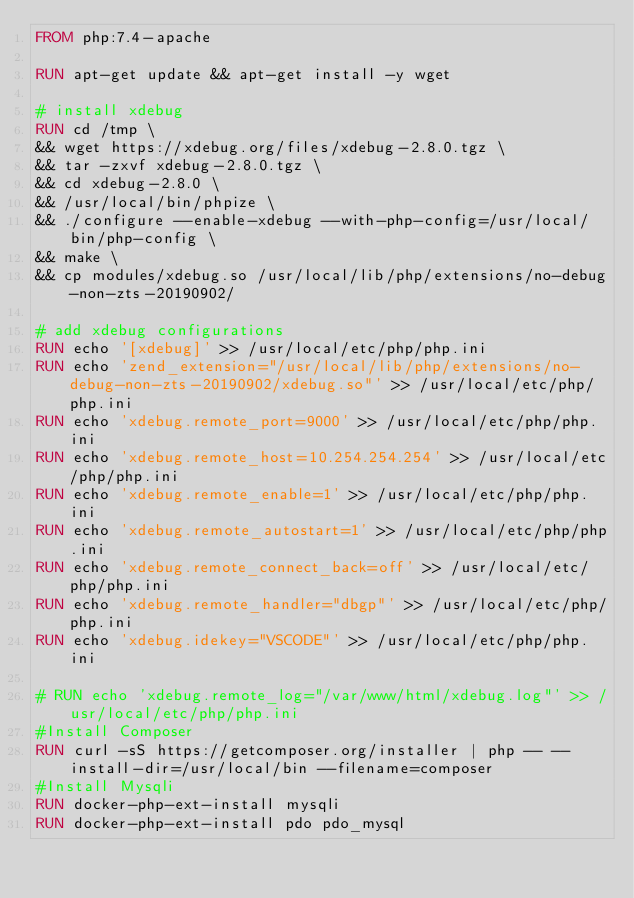Convert code to text. <code><loc_0><loc_0><loc_500><loc_500><_Dockerfile_>FROM php:7.4-apache

RUN apt-get update && apt-get install -y wget 

# install xdebug 
RUN cd /tmp \
&& wget https://xdebug.org/files/xdebug-2.8.0.tgz \
&& tar -zxvf xdebug-2.8.0.tgz \
&& cd xdebug-2.8.0 \
&& /usr/local/bin/phpize \
&& ./configure --enable-xdebug --with-php-config=/usr/local/bin/php-config \
&& make \
&& cp modules/xdebug.so /usr/local/lib/php/extensions/no-debug-non-zts-20190902/

# add xdebug configurations
RUN echo '[xdebug]' >> /usr/local/etc/php/php.ini
RUN echo 'zend_extension="/usr/local/lib/php/extensions/no-debug-non-zts-20190902/xdebug.so"' >> /usr/local/etc/php/php.ini
RUN echo 'xdebug.remote_port=9000' >> /usr/local/etc/php/php.ini
RUN echo 'xdebug.remote_host=10.254.254.254' >> /usr/local/etc/php/php.ini
RUN echo 'xdebug.remote_enable=1' >> /usr/local/etc/php/php.ini
RUN echo 'xdebug.remote_autostart=1' >> /usr/local/etc/php/php.ini
RUN echo 'xdebug.remote_connect_back=off' >> /usr/local/etc/php/php.ini
RUN echo 'xdebug.remote_handler="dbgp"' >> /usr/local/etc/php/php.ini
RUN echo 'xdebug.idekey="VSCODE"' >> /usr/local/etc/php/php.ini

# RUN echo 'xdebug.remote_log="/var/www/html/xdebug.log"' >> /usr/local/etc/php/php.ini
#Install Composer
RUN curl -sS https://getcomposer.org/installer | php -- --install-dir=/usr/local/bin --filename=composer
#Install Mysqli
RUN docker-php-ext-install mysqli
RUN docker-php-ext-install pdo pdo_mysql
</code> 